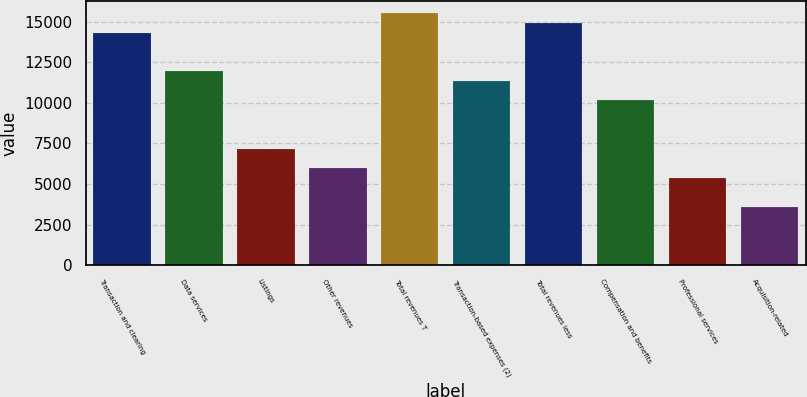Convert chart. <chart><loc_0><loc_0><loc_500><loc_500><bar_chart><fcel>Transaction and clearing<fcel>Data services<fcel>Listings<fcel>Other revenues<fcel>Total revenues T<fcel>Transaction-based expenses (2)<fcel>Total revenues less<fcel>Compensation and benefits<fcel>Professional services<fcel>Acquisition-related<nl><fcel>14329.4<fcel>11941.3<fcel>7165.04<fcel>5970.98<fcel>15523.5<fcel>11344.2<fcel>14926.4<fcel>10150.2<fcel>5373.95<fcel>3582.86<nl></chart> 